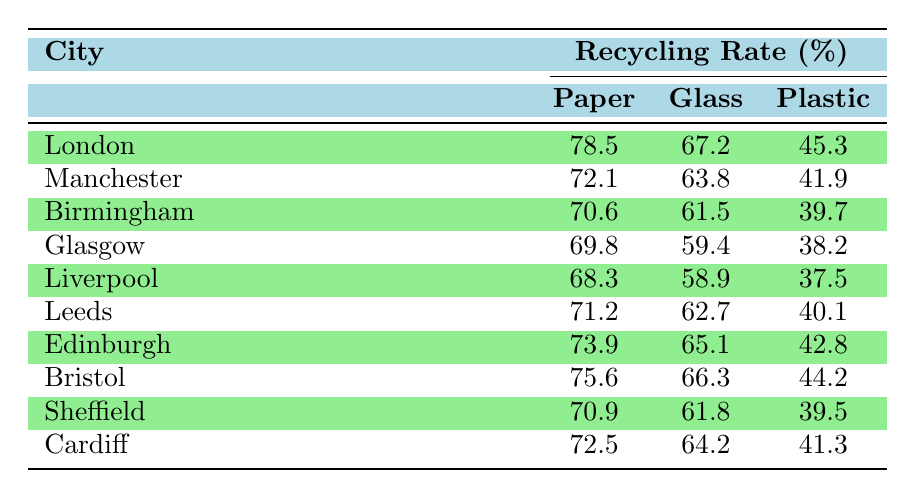What is the recycling rate for paper in London? The table shows that the recycling rate for paper in London is listed as 78.5% under the heading "Recycling Rate (%)".
Answer: 78.5% Which city has the highest recycling rate for glass? By examining the "Glass" column in the table, Bristol has the highest glass recycling rate at 66.3%.
Answer: Bristol How does Manchester's recycling rate for plastic compare to Birmingham's? The recycling rate for plastic in Manchester is 41.9% while Birmingham's is 39.7%. Therefore, Manchester's rate is higher by 2.2%.
Answer: Manchester's rate is higher by 2.2% What is the average recycling rate for paper across all listed cities? To find the average, add the paper recycling rates: 78.5 + 72.1 + 70.6 + 69.8 + 68.3 + 71.2 + 73.9 + 75.6 + 70.9 + 72.5 = 711.5. Then, divide by the number of cities (10): 711.5 / 10 = 71.15.
Answer: 71.15 Is the recycling rate for plastic in Glasgow higher than that in Liverpool? Glasgow's recycling rate for plastic is 38.2%, while Liverpool's is 37.5%. Since 38.2% is greater than 37.5%, it is true that Glasgow's rate is higher.
Answer: Yes What is the difference in the recycling rates for glass between Leeds and Cardiff? The glass recycling rate for Leeds is 62.7%, and for Cardiff, it is 64.2%. The difference is calculated as follows: 64.2 - 62.7 = 1.5%.
Answer: 1.5% Which material has the lowest recycling rate overall in the cities listed? By reviewing the table, the lowest recycling rate for plastic appears in Glasgow at 38.2%, making it the overall lowest compared to paper and glass rates.
Answer: Plastic If we combine the paper recycling rates of Birmingham and Sheffield, what is their total? The paper recycling rate for Birmingham is 70.6% and for Sheffield, it is 70.9%. Adding these together gives 70.6 + 70.9 = 141.5%.
Answer: 141.5% Which city has a recycling rate for glass that is below 60%? Glasgow has a glass recycling rate of 59.4%, which is the only city with a rate below 60% according to the table.
Answer: Glasgow Are Edinburgh’s recycling rates for paper and plastic both above 70%? Edinburgh has a paper rate of 73.9%, which is above 70%, but its plastic rate is 42.8%, which is below 70%. Therefore, not both rates are above 70%.
Answer: No 